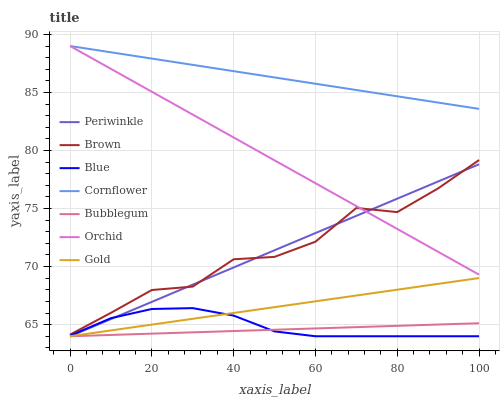Does Bubblegum have the minimum area under the curve?
Answer yes or no. Yes. Does Cornflower have the maximum area under the curve?
Answer yes or no. Yes. Does Brown have the minimum area under the curve?
Answer yes or no. No. Does Brown have the maximum area under the curve?
Answer yes or no. No. Is Orchid the smoothest?
Answer yes or no. Yes. Is Brown the roughest?
Answer yes or no. Yes. Is Gold the smoothest?
Answer yes or no. No. Is Gold the roughest?
Answer yes or no. No. Does Blue have the lowest value?
Answer yes or no. Yes. Does Brown have the lowest value?
Answer yes or no. No. Does Orchid have the highest value?
Answer yes or no. Yes. Does Brown have the highest value?
Answer yes or no. No. Is Blue less than Cornflower?
Answer yes or no. Yes. Is Brown greater than Bubblegum?
Answer yes or no. Yes. Does Periwinkle intersect Brown?
Answer yes or no. Yes. Is Periwinkle less than Brown?
Answer yes or no. No. Is Periwinkle greater than Brown?
Answer yes or no. No. Does Blue intersect Cornflower?
Answer yes or no. No. 